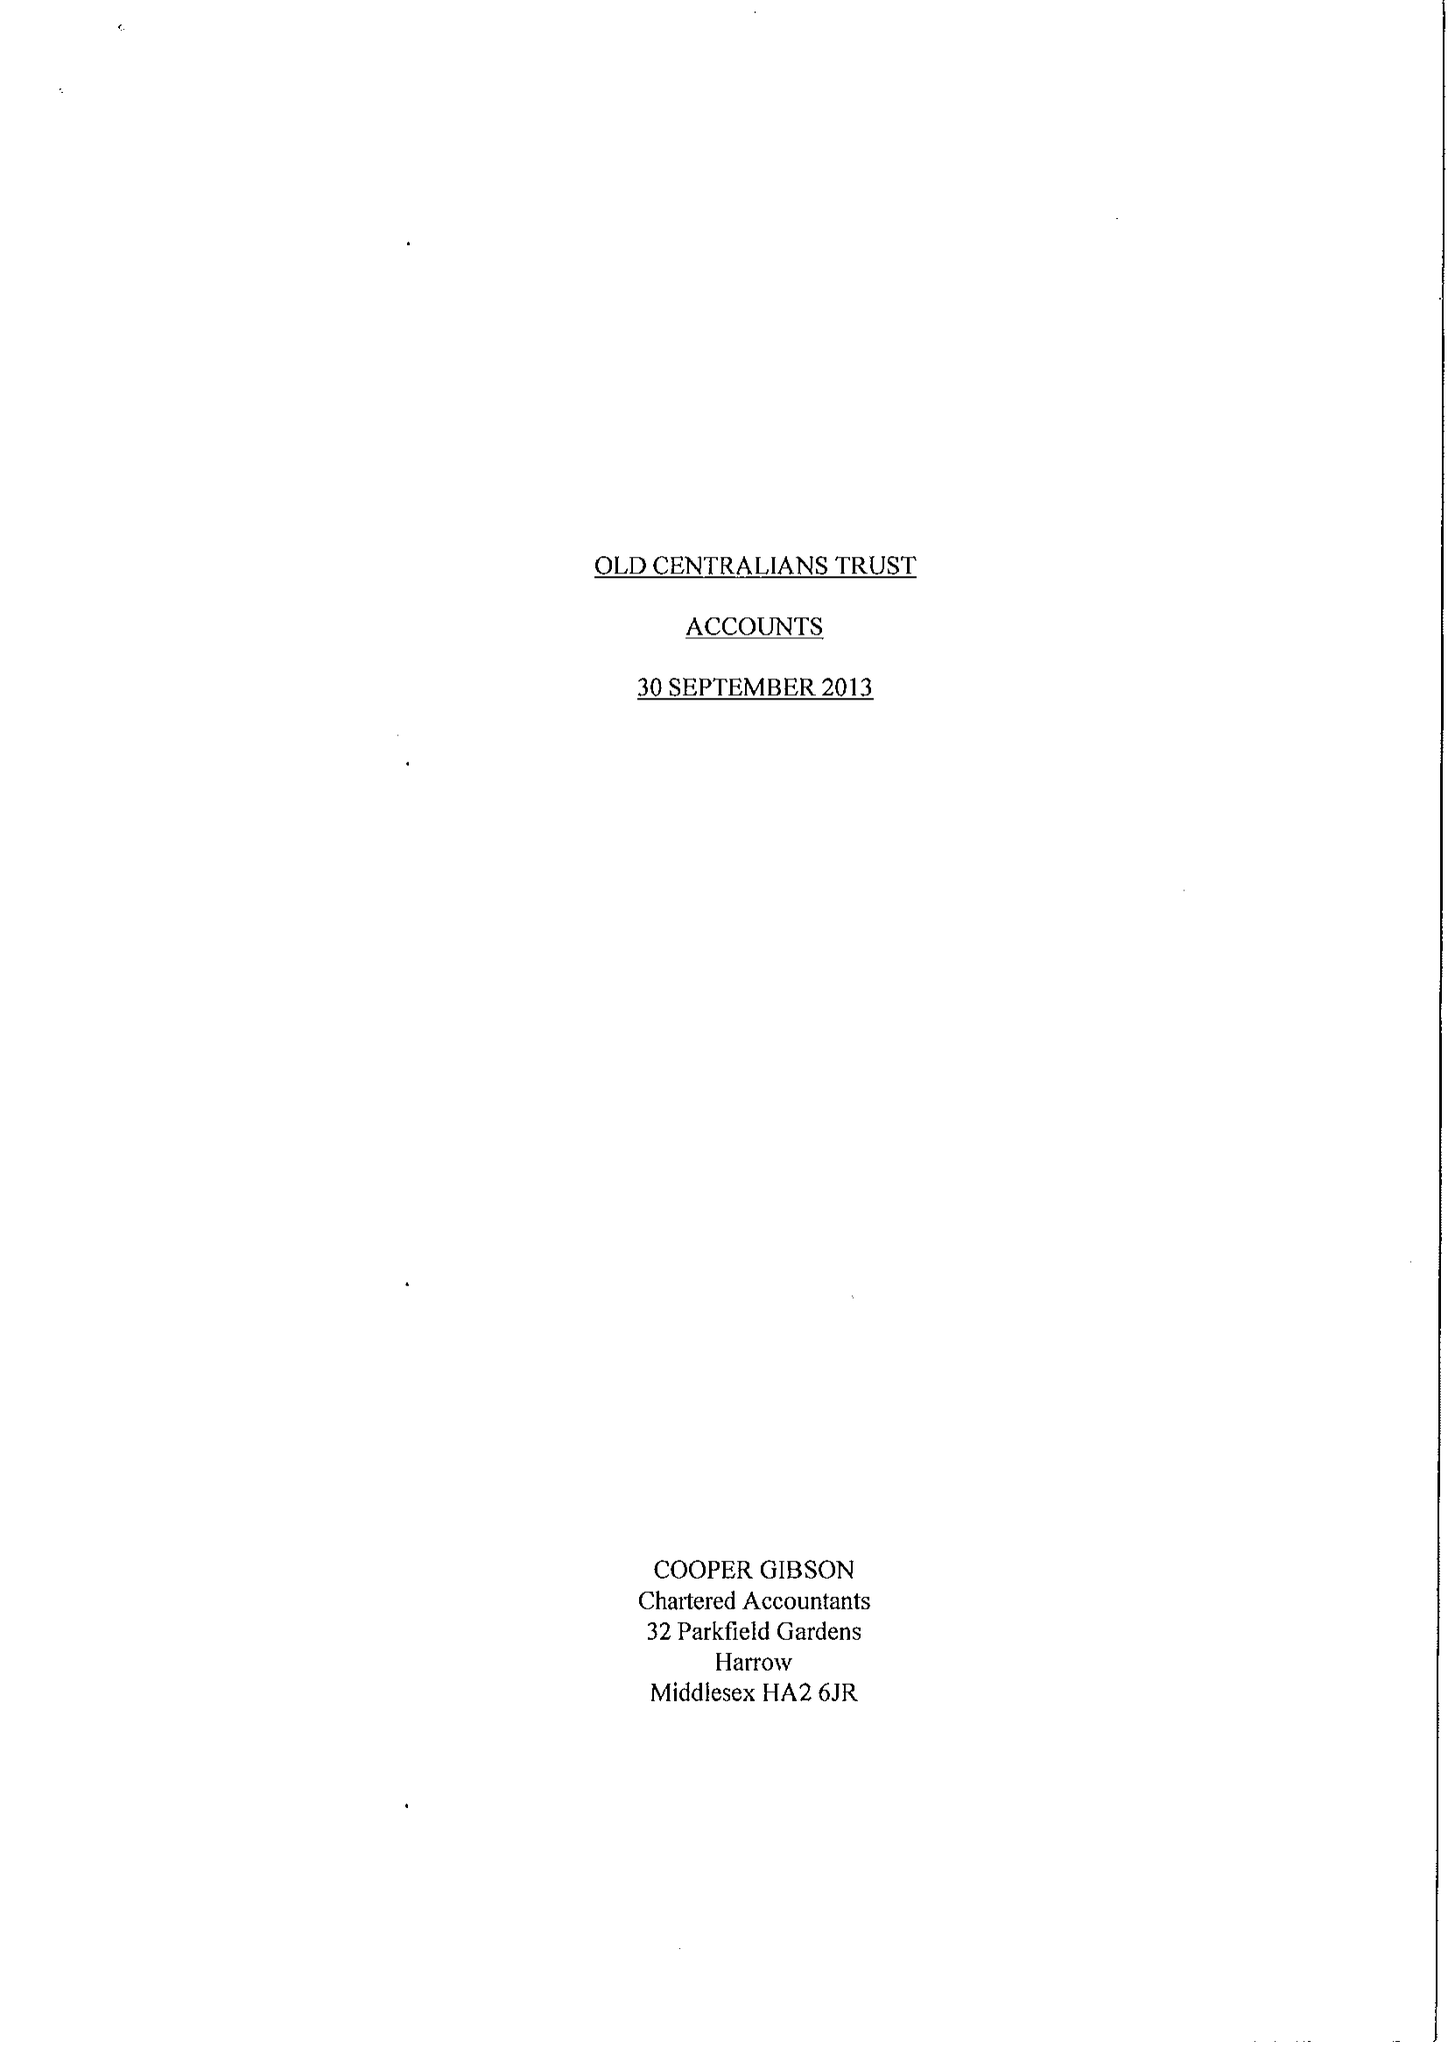What is the value for the charity_name?
Answer the question using a single word or phrase. Old Centralians Trust 